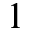Convert formula to latex. <formula><loc_0><loc_0><loc_500><loc_500>1</formula> 